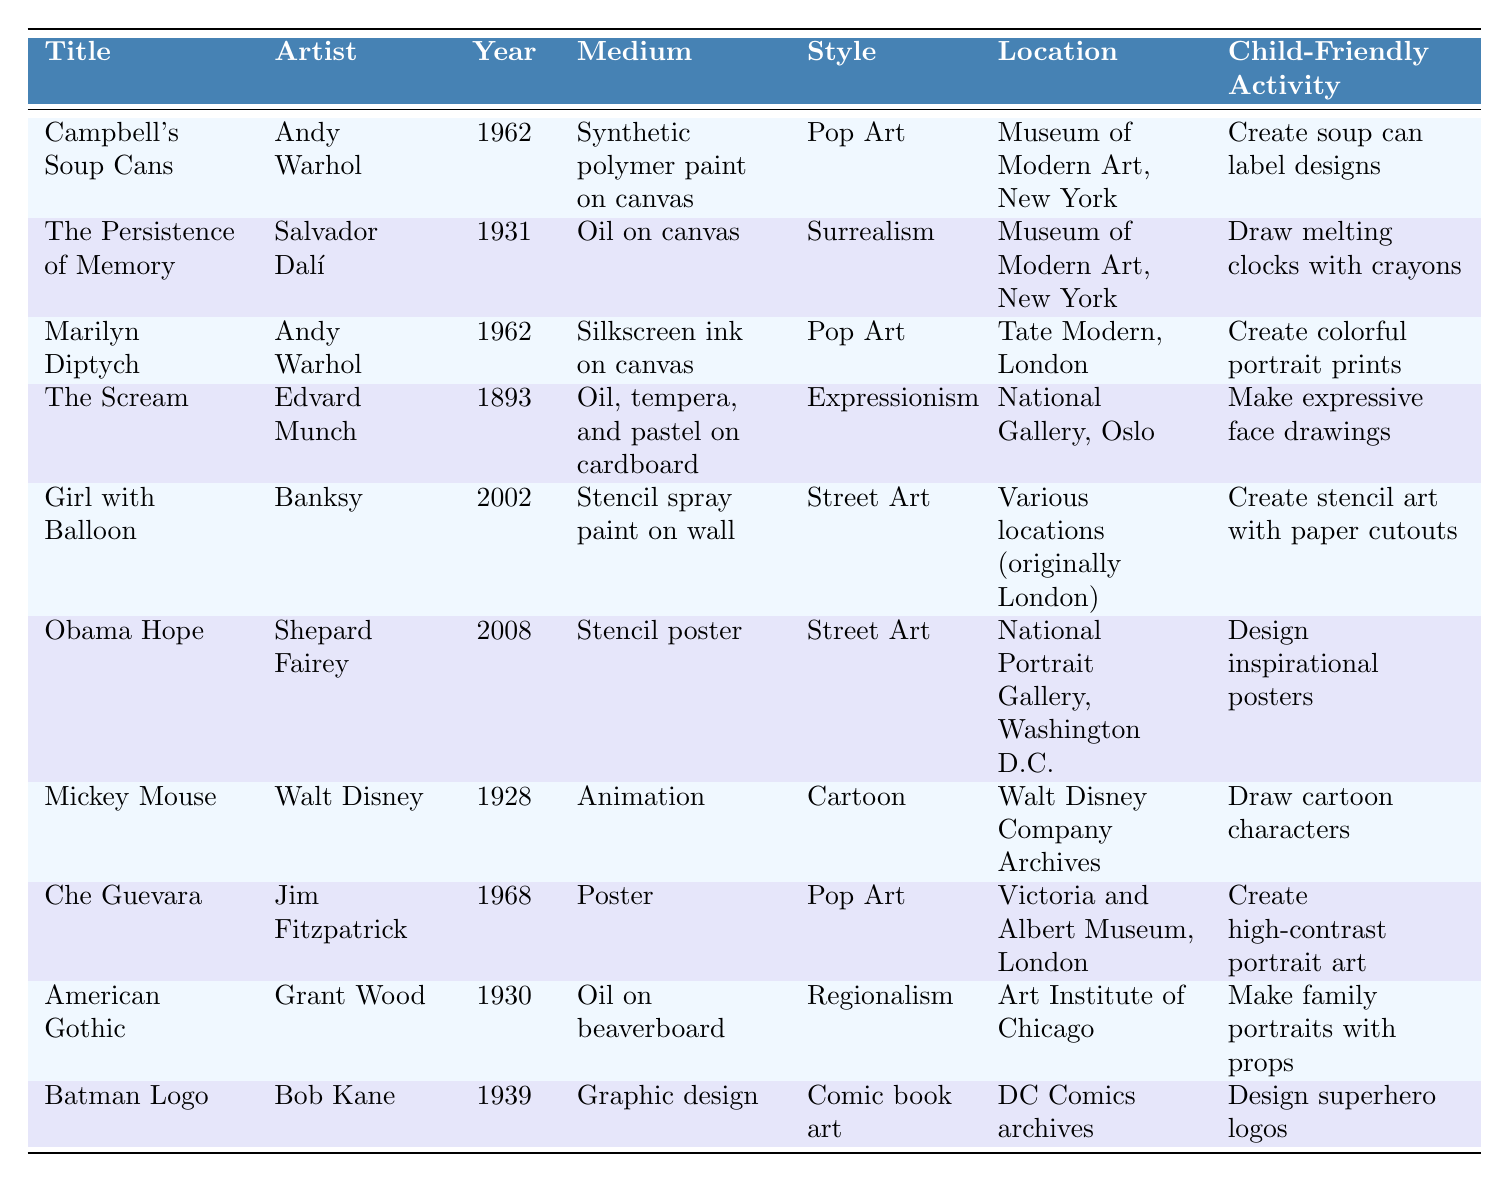What is the medium used in "The Persistence of Memory"? The table lists "The Persistence of Memory" and states that the medium is "Oil on canvas."
Answer: Oil on canvas Which artist created the "Marilyn Diptych"? By looking at the table, we see that the "Marilyn Diptych" was created by Andy Warhol.
Answer: Andy Warhol How many artworks in the table are from the year 2008? The table shows one artwork from 2008, which is "Obama Hope."
Answer: 1 What is the style of "Girl with Balloon"? According to the table, the style of "Girl with Balloon" is "Street Art."
Answer: Street Art Which artwork has the oldest creation year? A review of the years in the table reveals that "The Scream," created in 1893, is the oldest.
Answer: The Scream Is "Mickey Mouse" included in the Pop Art style? The table indicates that "Mickey Mouse" is categorized under the style "Cartoon," not "Pop Art," making the statement false.
Answer: No What is the location of the "Campbell's Soup Cans"? The table explicitly states that "Campbell's Soup Cans" is located in the "Museum of Modern Art, New York."
Answer: Museum of Modern Art, New York How many different artists are represented in the table? By examining the artist column, we find 8 unique names, which indicates that there are 8 different artists represented.
Answer: 8 What activities could children do related to "American Gothic"? The table lists the activity for "American Gothic" as "Make family portraits with props."
Answer: Make family portraits with props Which two artworks were created by Andy Warhol? A scan of the table shows that "Campbell's Soup Cans" and "Marilyn Diptych" are both created by Andy Warhol.
Answer: Campbell's Soup Cans, Marilyn Diptych Which artwork's medium is a stencil? The table highlights that both "Obama Hope" and "Girl with Balloon" have stencils as their medium.
Answer: Obama Hope, Girl with Balloon 